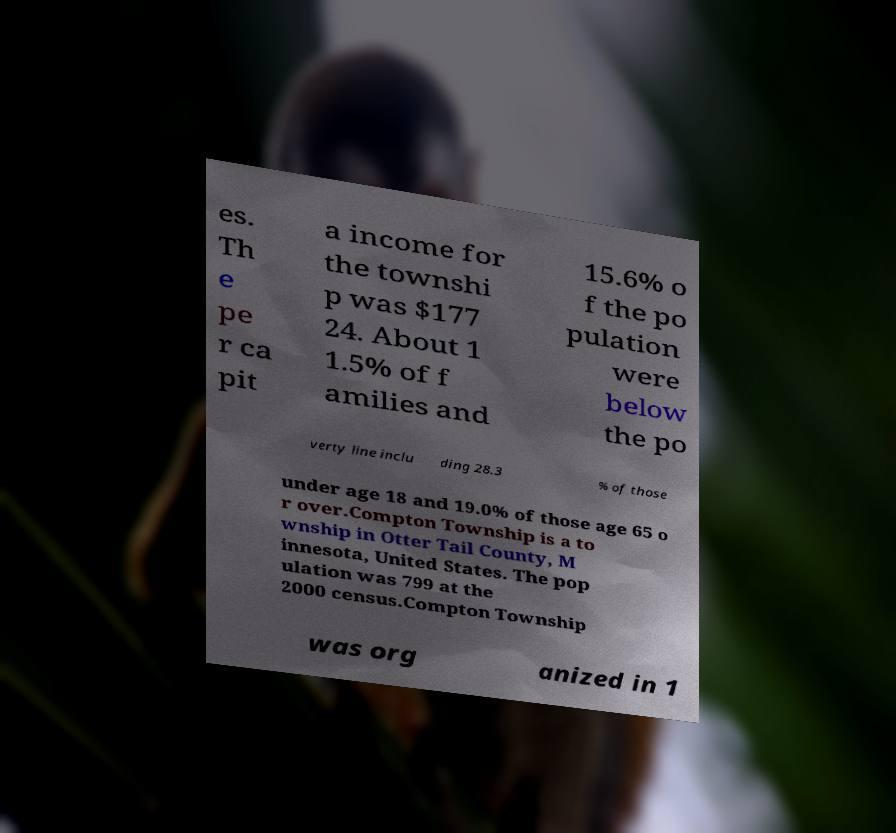For documentation purposes, I need the text within this image transcribed. Could you provide that? es. Th e pe r ca pit a income for the townshi p was $177 24. About 1 1.5% of f amilies and 15.6% o f the po pulation were below the po verty line inclu ding 28.3 % of those under age 18 and 19.0% of those age 65 o r over.Compton Township is a to wnship in Otter Tail County, M innesota, United States. The pop ulation was 799 at the 2000 census.Compton Township was org anized in 1 